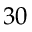Convert formula to latex. <formula><loc_0><loc_0><loc_500><loc_500>3 0</formula> 